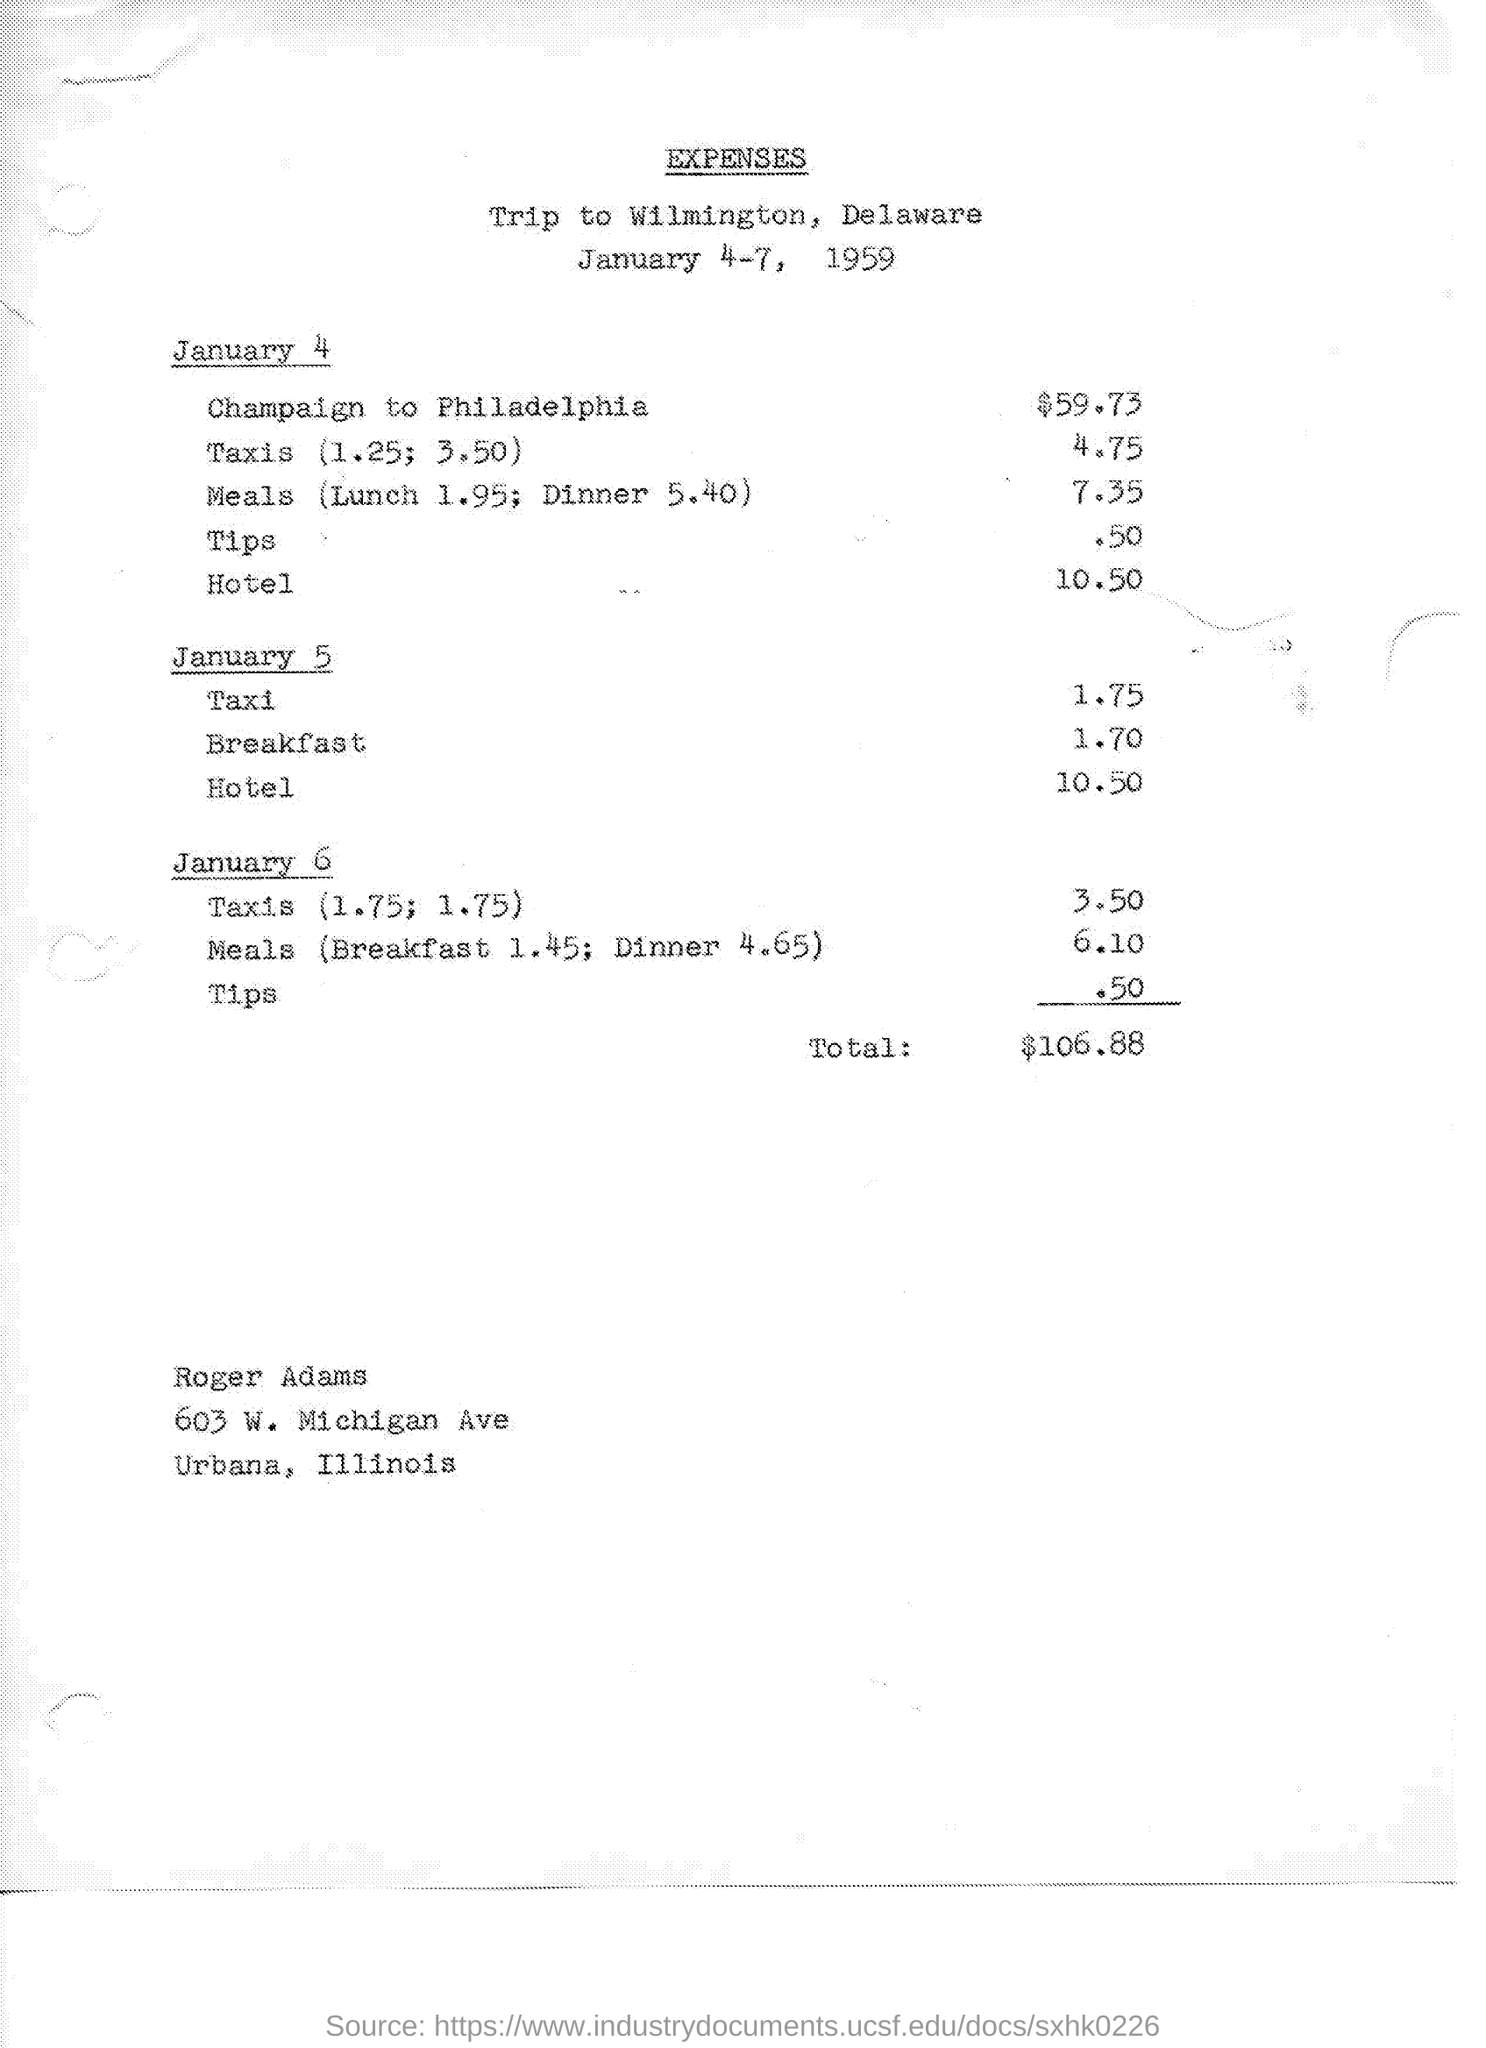Give some essential details in this illustration. On January 6th, the cost of tips is 50 cents. On January 4, the cost for meals was 7.35... The total expenses mentioned on the given page are $106.88. On January 6, the cost of meals was 6.10. On January 5, the cost of the hotel was 10.50. 